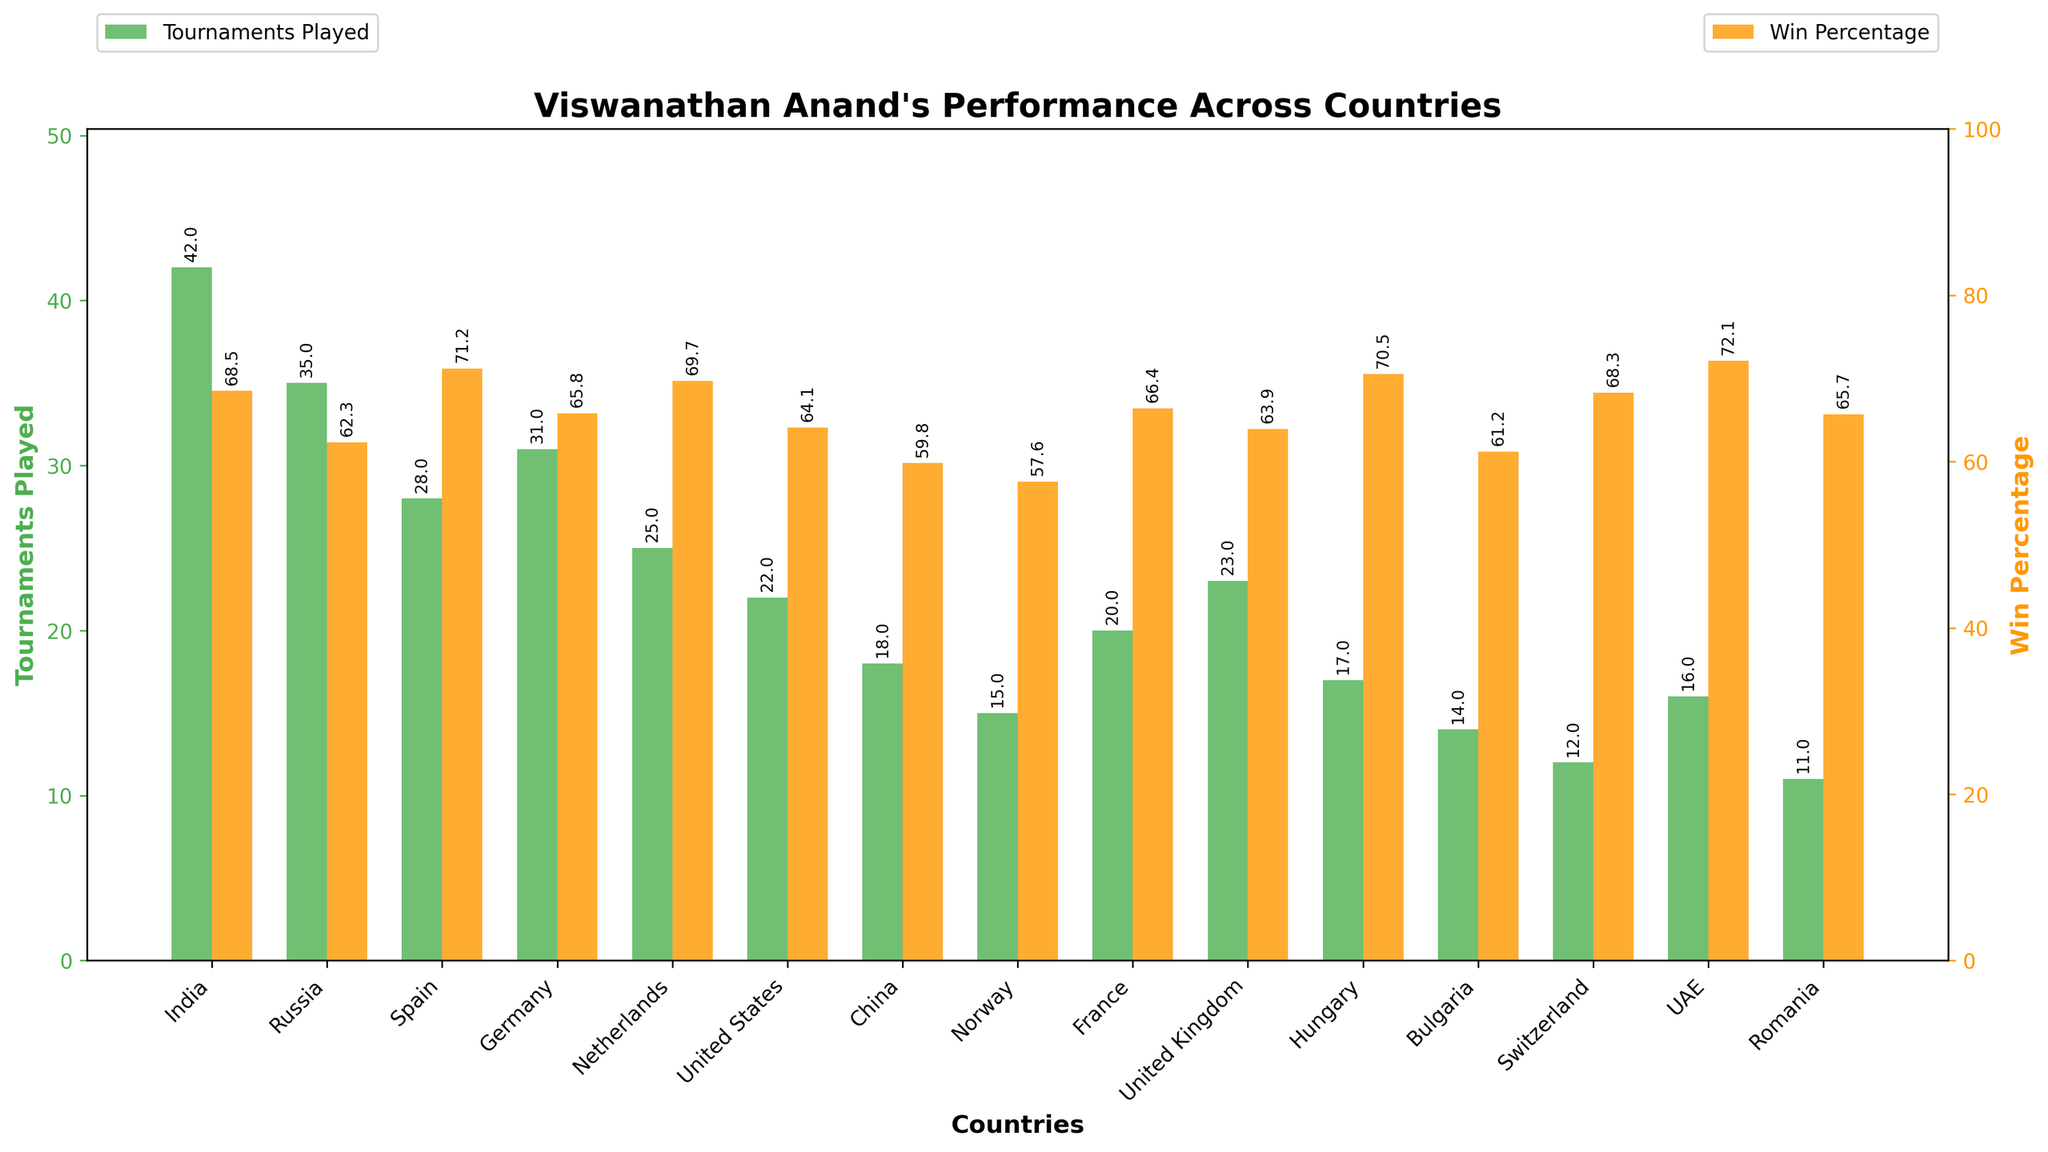Which country has the highest win percentage? To find the country with the highest win percentage, look at the highest orange bars. The UAE has the highest win percentage with 72.1%.
Answer: UAE Which country has the lowest win percentage? To find the country with the lowest win percentage, identify the shortest orange bar. Norway has the lowest win percentage at 57.6%.
Answer: Norway Between India and Russia, which country has the higher win percentage? Compare the orange bars for India and Russia. India's win percentage is 68.5%, which is higher than Russia's 62.3%.
Answer: India How many more tournaments did Anand play in India compared to China? Anand played 42 tournaments in India and 18 in China. The difference is 42 - 18 = 24 tournaments.
Answer: 24 What is the average win percentage across all countries? Sum all win percentages and divide by the number of countries. The sum is 68.5 + 62.3 + 71.2 + 65.8 + 69.7 + 64.1 + 59.8 + 57.6 + 66.4 + 63.9 + 70.5 + 61.2 + 68.3 + 72.1 + 65.7 = 986.1. Dividing by 15 countries, the average is 986.1 / 15 = 65.74%.
Answer: 65.74% Which two countries have the closest win percentages? Comparing all win percentages visually, Germany (65.8%) and Romania (65.7%) have the closest win percentages, differing by only 0.1%.
Answer: Germany and Romania How many countries have a win percentage above 70%? Count the number of orange bars with heights above 70. These countries are Spain (71.2%), Hungary (70.5%), and UAE (72.1%). There are 3 such countries.
Answer: 3 What is the combined number of tournaments played in France and the United Kingdom? France has 20 tournaments, and the United Kingdom has 23. The combined number is 20 + 23 = 43 tournaments.
Answer: 43 Which country did Anand play the second most number of tournaments in? After India, which has 42 tournaments, Russia with 35 tournaments is the country where Anand played the second most number of tournaments.
Answer: Russia Does Anand have a higher win percentage in Germany or the United States? Compare the heights of the orange bars for Germany (65.8%) and the United States (64.1%). Germany has a higher win percentage.
Answer: Germany 